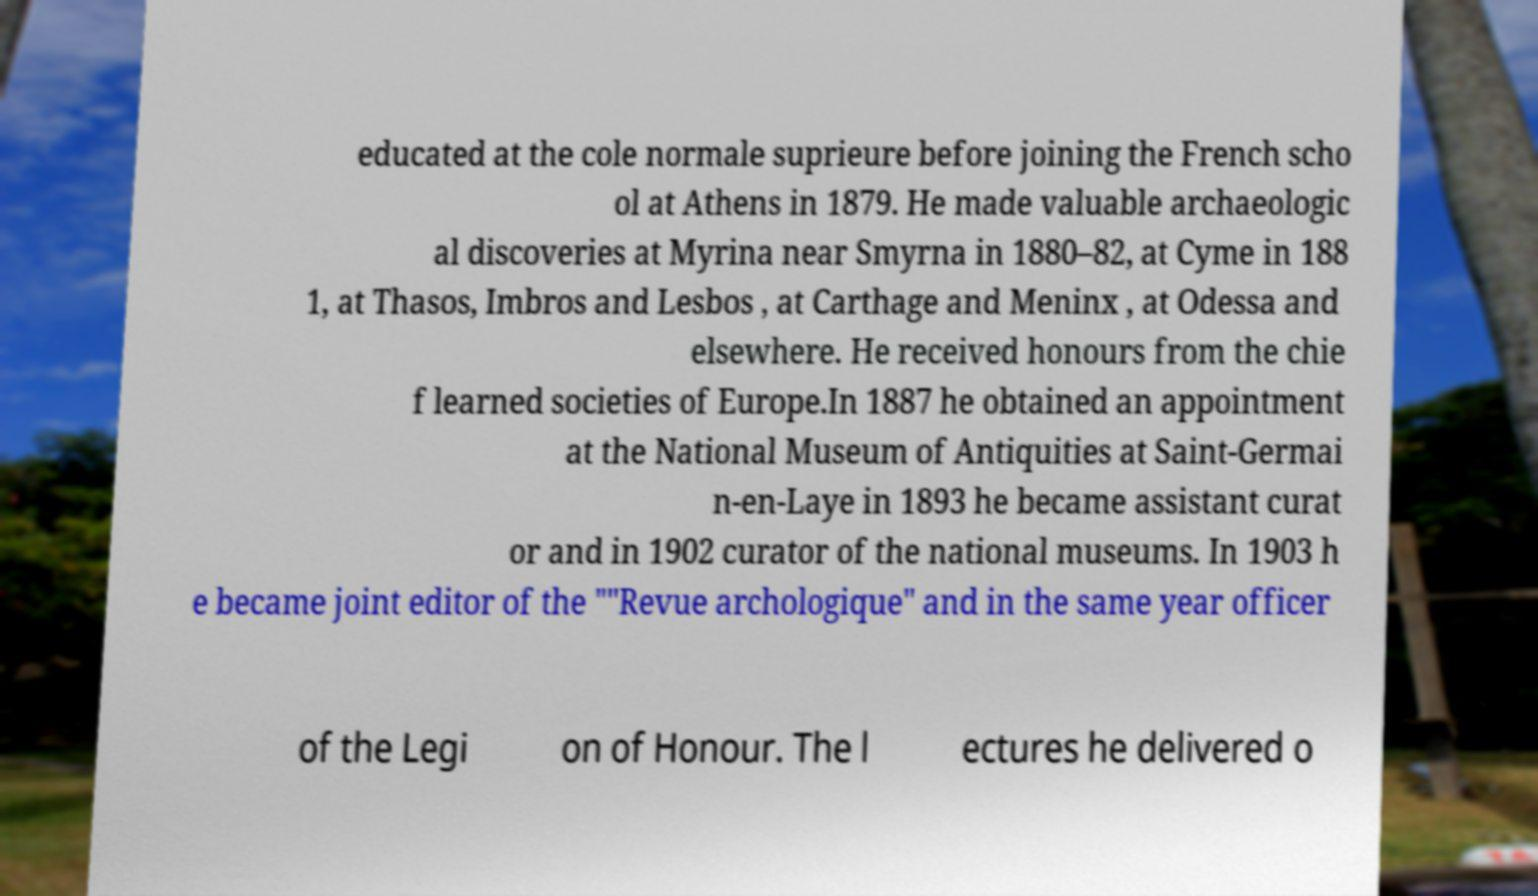Can you accurately transcribe the text from the provided image for me? educated at the cole normale suprieure before joining the French scho ol at Athens in 1879. He made valuable archaeologic al discoveries at Myrina near Smyrna in 1880–82, at Cyme in 188 1, at Thasos, Imbros and Lesbos , at Carthage and Meninx , at Odessa and elsewhere. He received honours from the chie f learned societies of Europe.In 1887 he obtained an appointment at the National Museum of Antiquities at Saint-Germai n-en-Laye in 1893 he became assistant curat or and in 1902 curator of the national museums. In 1903 h e became joint editor of the ""Revue archologique" and in the same year officer of the Legi on of Honour. The l ectures he delivered o 